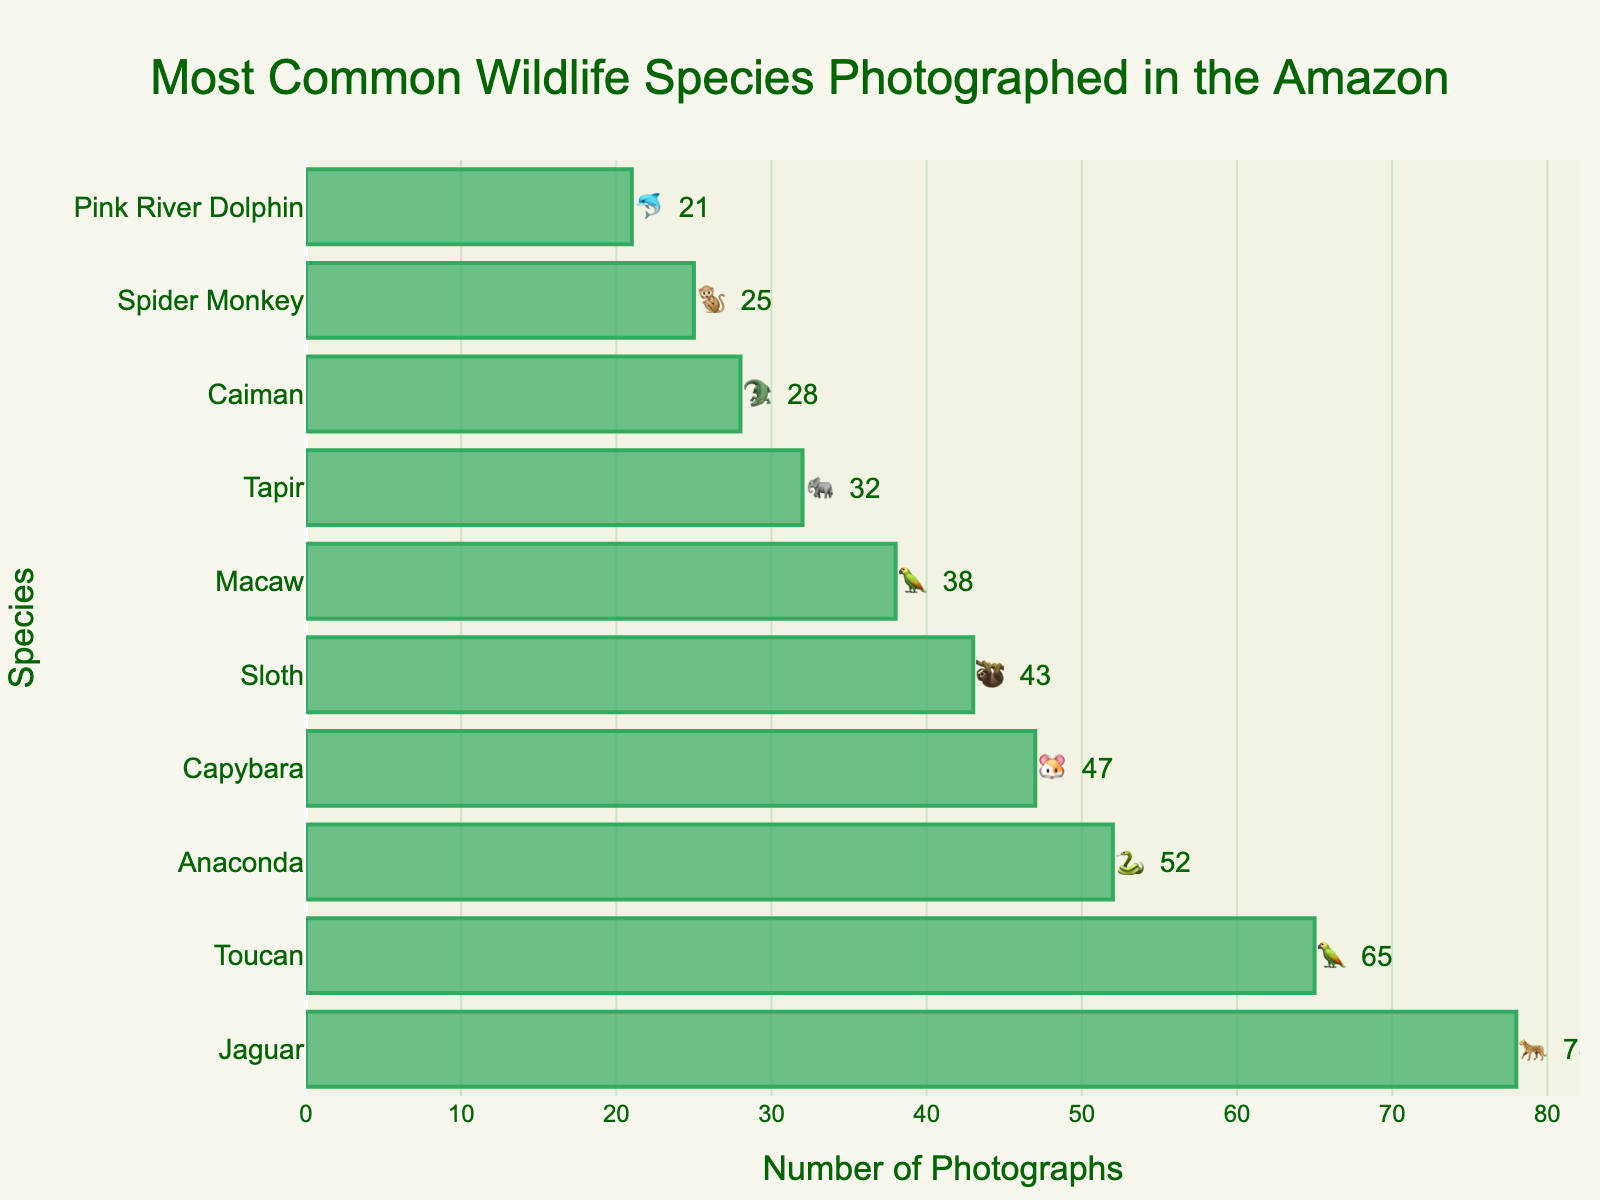How many species are represented in the chart? Count the number of different species.
Answer: 10 Which animal has the highest number of photographs taken? Identify the topmost bar in the chart, which represents the species with the highest number of photographs.
Answer: Jaguar How many more photographs were taken of jaguars compared to sloths? Find the count for both jaguars and sloths and subtract the number of sloth photographs from the number of jaguar photographs: 78 - 43.
Answer: 35 What is the total number of photographs taken of the top three species? Sum the counts of the top three species: Jaguar (78), Toucan (65), and Anaconda (52): 78 + 65 + 52.
Answer: 195 Is the number of Capybara photographs greater than the number of Sloth photographs? Compare the counts for Capybara (47) and Sloth (43).
Answer: Yes Which species has the fewest photographs taken? Identify the species with the smallest bar in the chart.
Answer: Pink River Dolphin How many photographs were taken of animals represented by emojis '🐘' and '🐬' together? Add the number of photographs taken of Tapir ('🐘', 32) and Pink River Dolphin ('🐬', 21): 32 + 21.
Answer: 53 What is the difference in the number of photographs between the species with the highest and the lowest counts? Subtract the count of the species with the lowest photographs (Pink River Dolphin, 21) from the highest (Jaguar, 78): 78 - 21.
Answer: 57 Which bird species has more photographs taken, Toucan or Macaw? Compare the counts for Toucan (65) and Macaw (38).
Answer: Toucan 